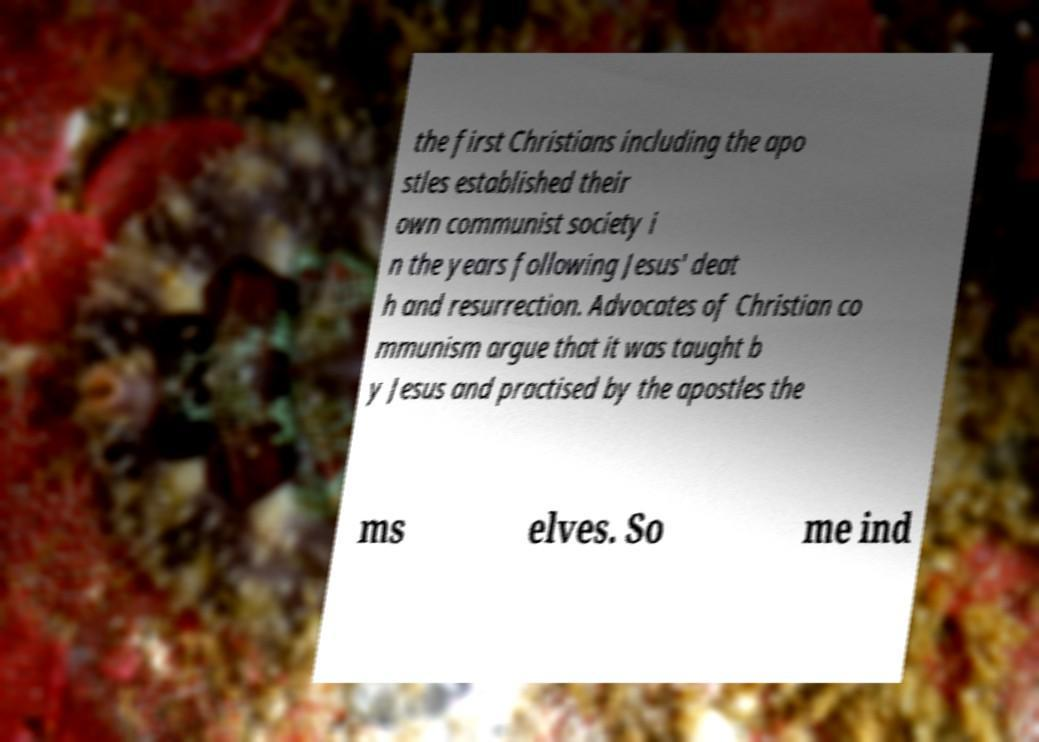Please read and relay the text visible in this image. What does it say? the first Christians including the apo stles established their own communist society i n the years following Jesus' deat h and resurrection. Advocates of Christian co mmunism argue that it was taught b y Jesus and practised by the apostles the ms elves. So me ind 